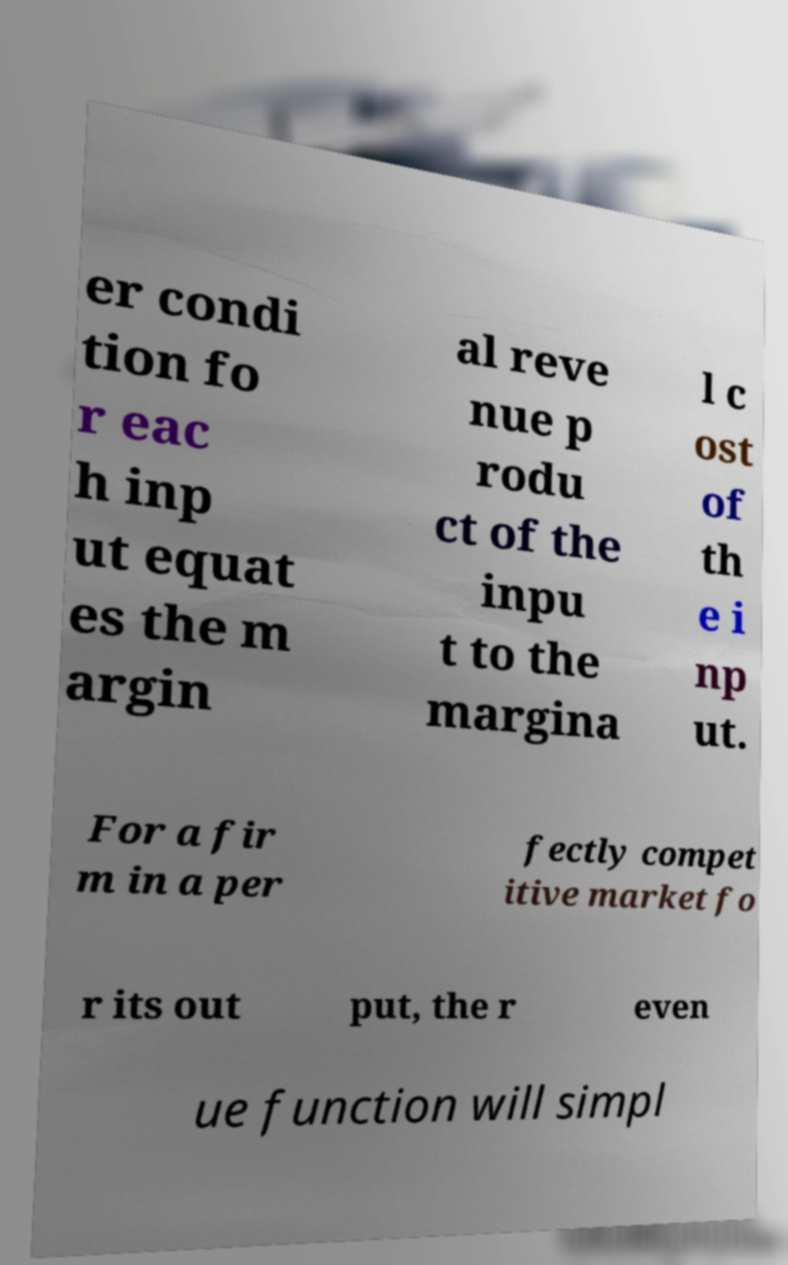There's text embedded in this image that I need extracted. Can you transcribe it verbatim? er condi tion fo r eac h inp ut equat es the m argin al reve nue p rodu ct of the inpu t to the margina l c ost of th e i np ut. For a fir m in a per fectly compet itive market fo r its out put, the r even ue function will simpl 